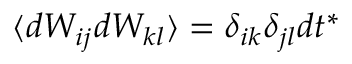<formula> <loc_0><loc_0><loc_500><loc_500>\langle d W _ { i j } d W _ { k l } \rangle = \delta _ { i k } \delta _ { j l } d t ^ { * }</formula> 